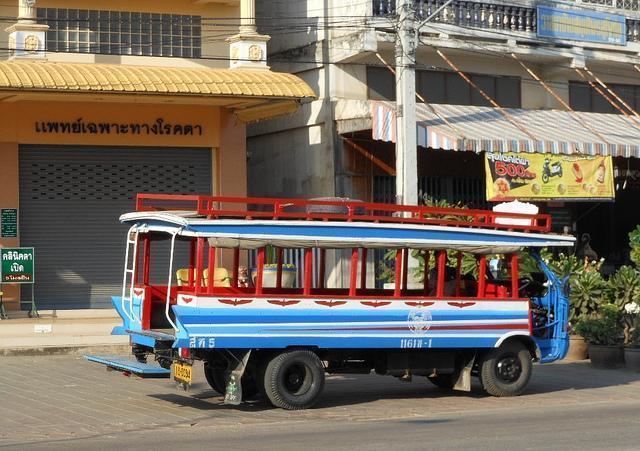The color scheme of this vehicle represents what flag?
From the following four choices, select the correct answer to address the question.
Options: Kazakhstan, djibouti, france, mexico. France. 